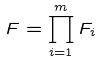<formula> <loc_0><loc_0><loc_500><loc_500>F = \prod _ { i = 1 } ^ { m } F _ { i }</formula> 